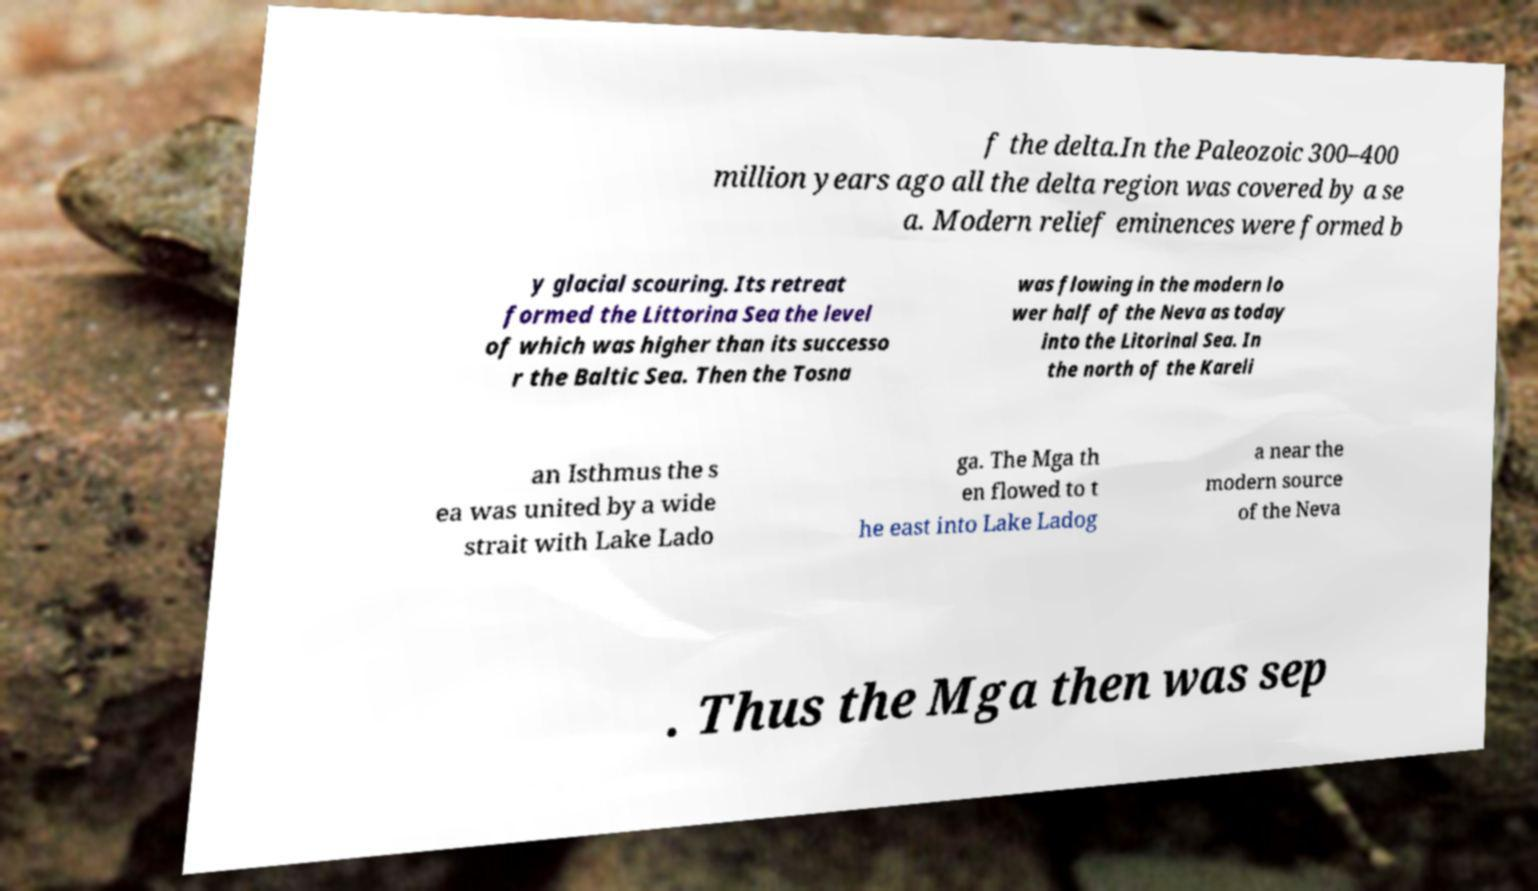What messages or text are displayed in this image? I need them in a readable, typed format. f the delta.In the Paleozoic 300–400 million years ago all the delta region was covered by a se a. Modern relief eminences were formed b y glacial scouring. Its retreat formed the Littorina Sea the level of which was higher than its successo r the Baltic Sea. Then the Tosna was flowing in the modern lo wer half of the Neva as today into the Litorinal Sea. In the north of the Kareli an Isthmus the s ea was united by a wide strait with Lake Lado ga. The Mga th en flowed to t he east into Lake Ladog a near the modern source of the Neva . Thus the Mga then was sep 